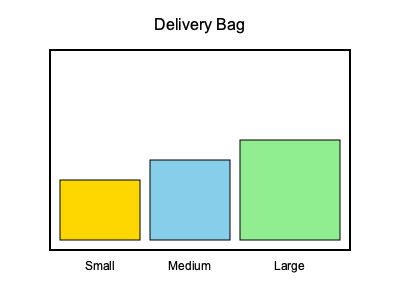You need to stack three packages of different sizes in your delivery bag. The small package measures 20x15x15 cm, the medium package is 20x20x20 cm, and the large package is 25x25x25 cm. What is the minimum height of the stack if you arrange them optimally? To find the minimum height of the stack, we need to arrange the packages optimally:

1. Start with the largest package (25x25x25 cm) as the base.
2. Place the medium package (20x20x20 cm) on top of the large package.
3. Finally, place the small package (20x15x15 cm) on top of the medium package.

The height of the stack will be the sum of the heights of each package:

$$ \text{Total Height} = 25 \text{ cm} + 20 \text{ cm} + 15 \text{ cm} = 60 \text{ cm} $$

This arrangement ensures the most stable configuration while minimizing the total height of the stack.
Answer: 60 cm 